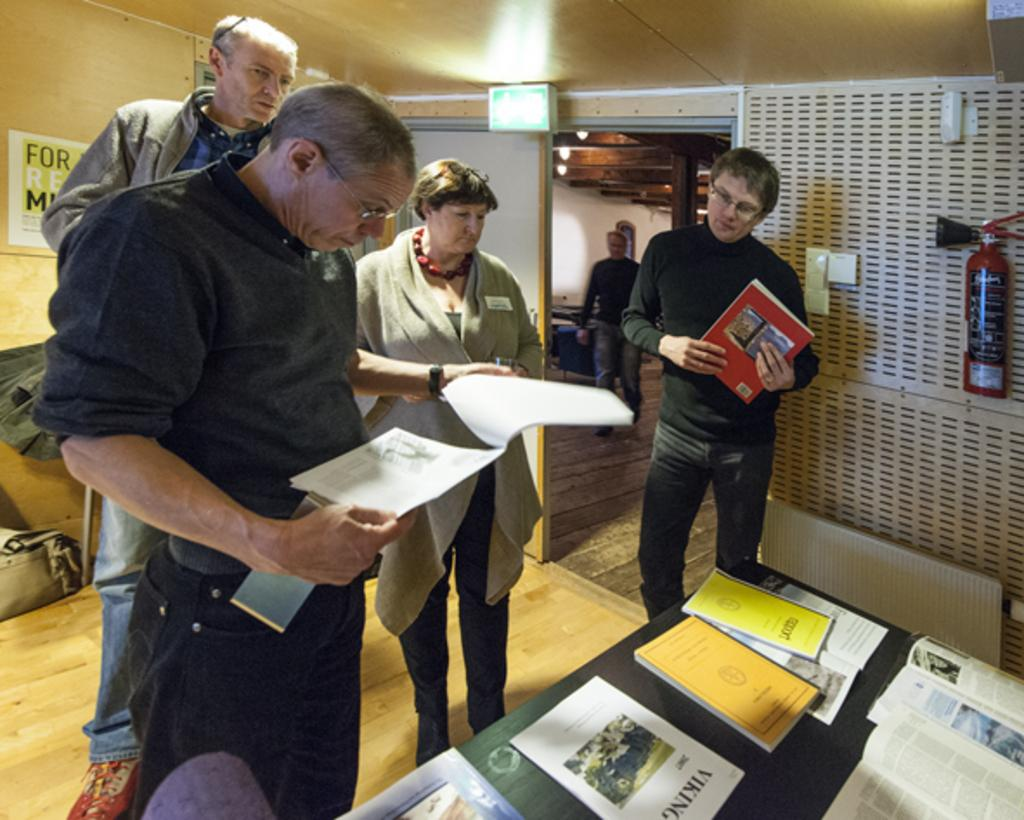<image>
Create a compact narrative representing the image presented. Some people read the paper and one paper has Viking on it 